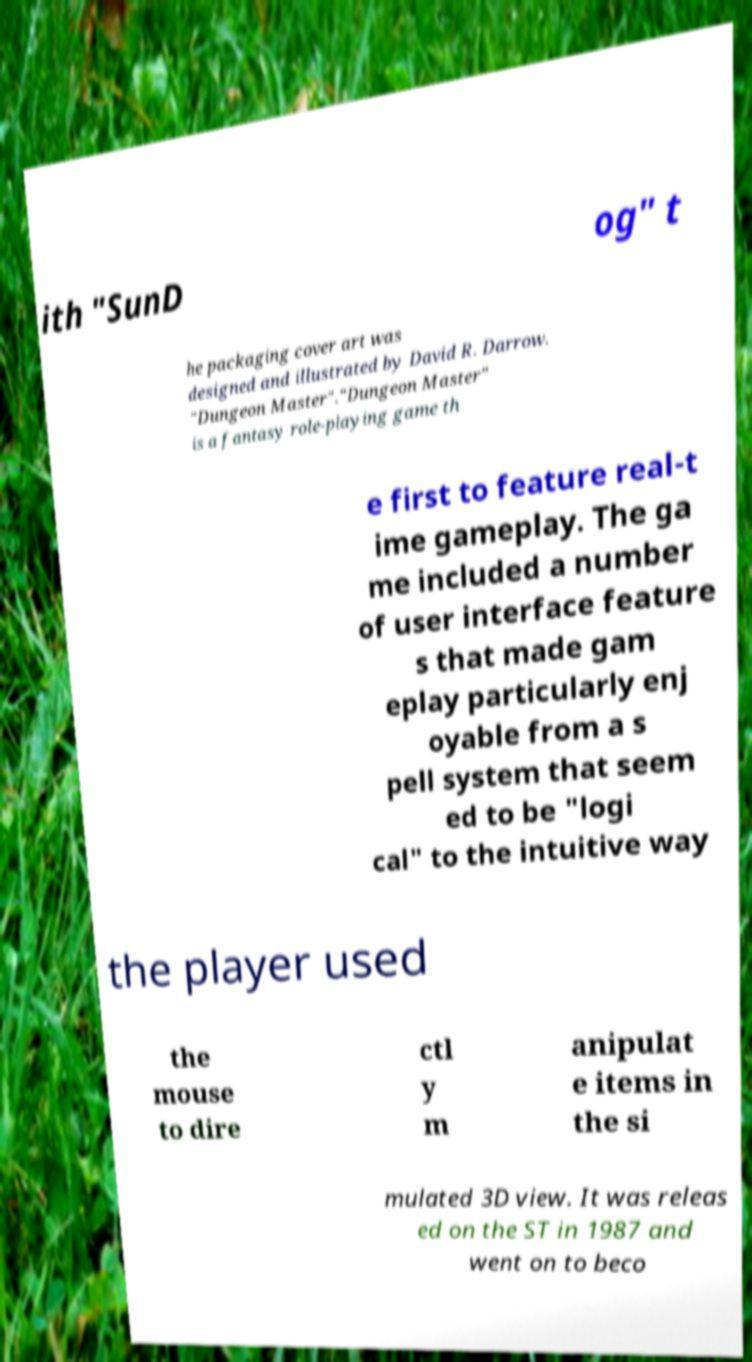For documentation purposes, I need the text within this image transcribed. Could you provide that? ith "SunD og" t he packaging cover art was designed and illustrated by David R. Darrow. "Dungeon Master"."Dungeon Master" is a fantasy role-playing game th e first to feature real-t ime gameplay. The ga me included a number of user interface feature s that made gam eplay particularly enj oyable from a s pell system that seem ed to be "logi cal" to the intuitive way the player used the mouse to dire ctl y m anipulat e items in the si mulated 3D view. It was releas ed on the ST in 1987 and went on to beco 